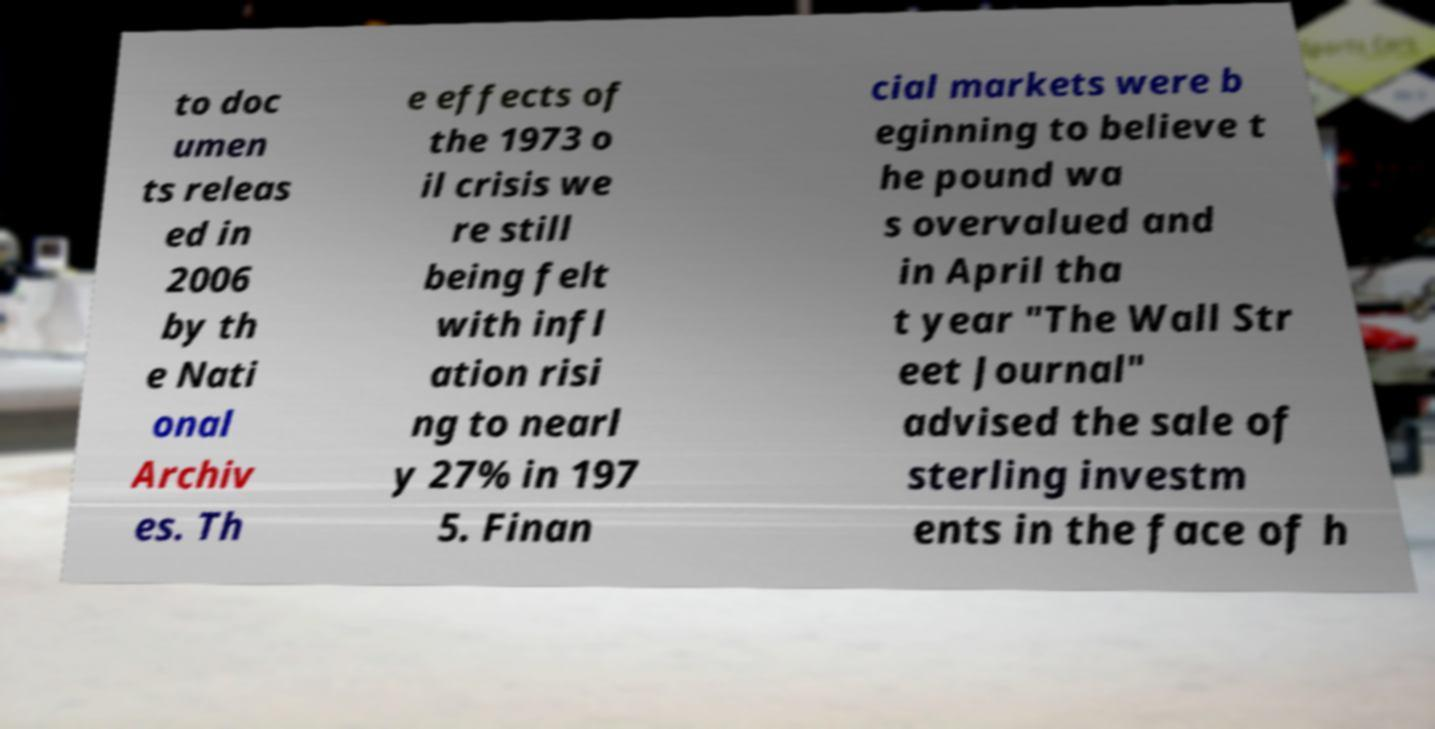Please identify and transcribe the text found in this image. to doc umen ts releas ed in 2006 by th e Nati onal Archiv es. Th e effects of the 1973 o il crisis we re still being felt with infl ation risi ng to nearl y 27% in 197 5. Finan cial markets were b eginning to believe t he pound wa s overvalued and in April tha t year "The Wall Str eet Journal" advised the sale of sterling investm ents in the face of h 